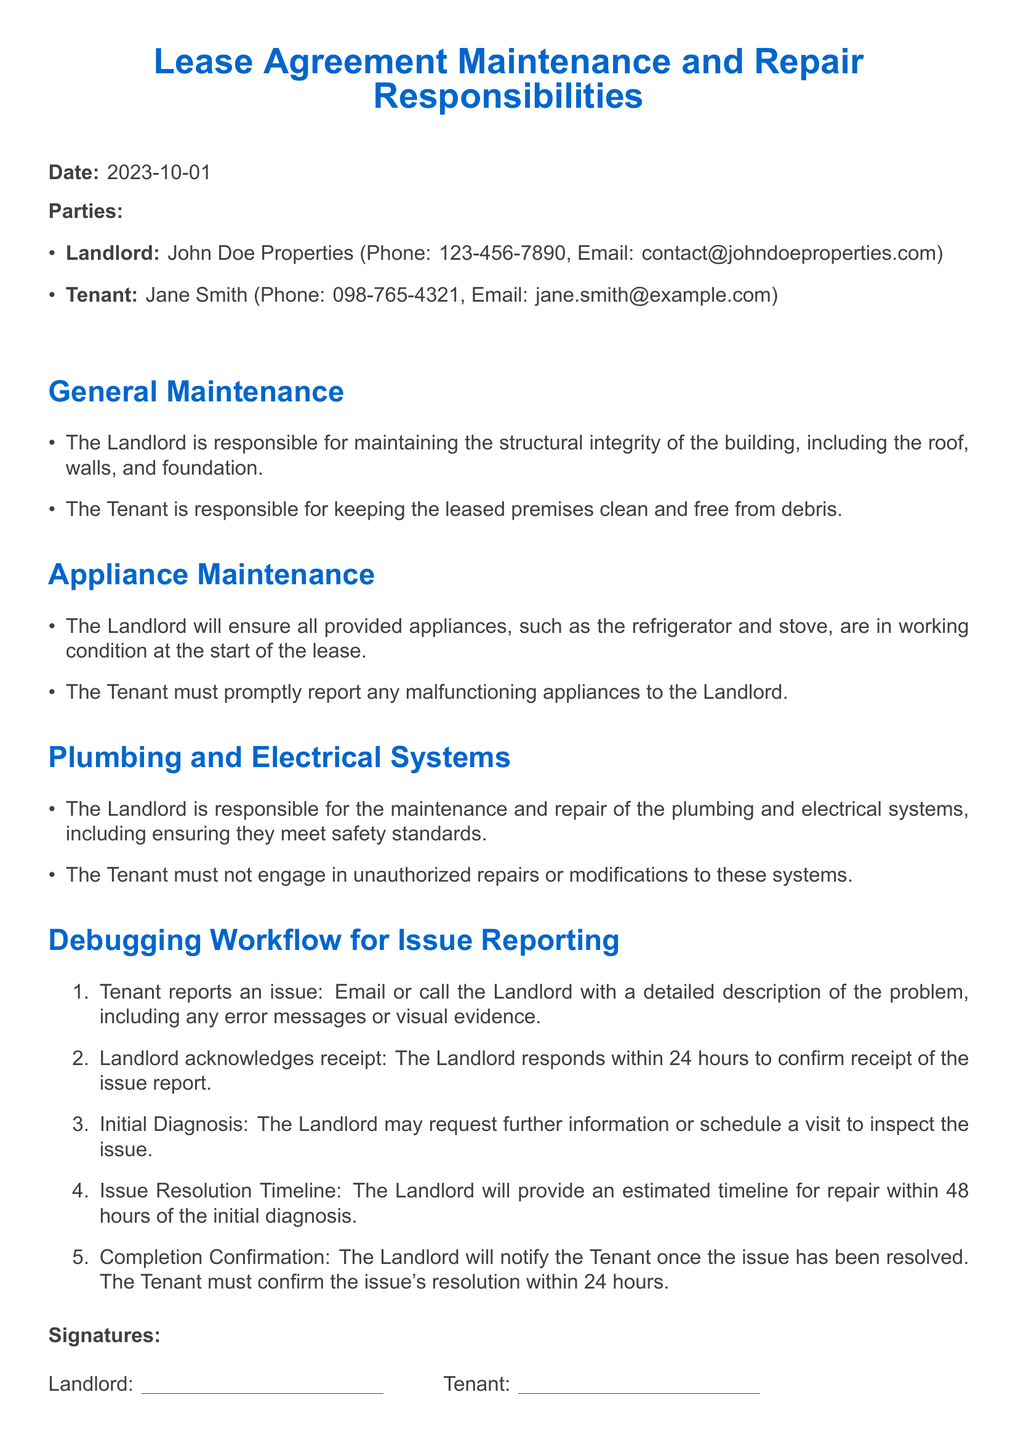What is the date of the lease agreement? The date is specified at the beginning of the document.
Answer: 2023-10-01 Who is the landlord? The landlord's name is mentioned in the parties section.
Answer: John Doe Properties What is the landlord's email address? The contact information for the landlord includes an email address.
Answer: contact@johndoeproperties.com What must the tenant do if appliances malfunction? This detail is outlined under the appliance maintenance section.
Answer: Promptly report the malfunction Who is responsible for plumbing maintenance? The responsibility for plumbing is stated in the plumbing and electrical systems section.
Answer: The Landlord What is the first step in the issue reporting workflow? The workflow outlines the initial step for reporting issues.
Answer: Tenant reports an issue How quickly must the landlord acknowledge receipt of an issue report? The timeline for acknowledgment is specified in the debugging workflow section.
Answer: Within 24 hours What must the tenant confirm after the issue resolution? The requirement for tenant confirmation post-resolution is provided in the workflow section.
Answer: Confirm the issue's resolution 